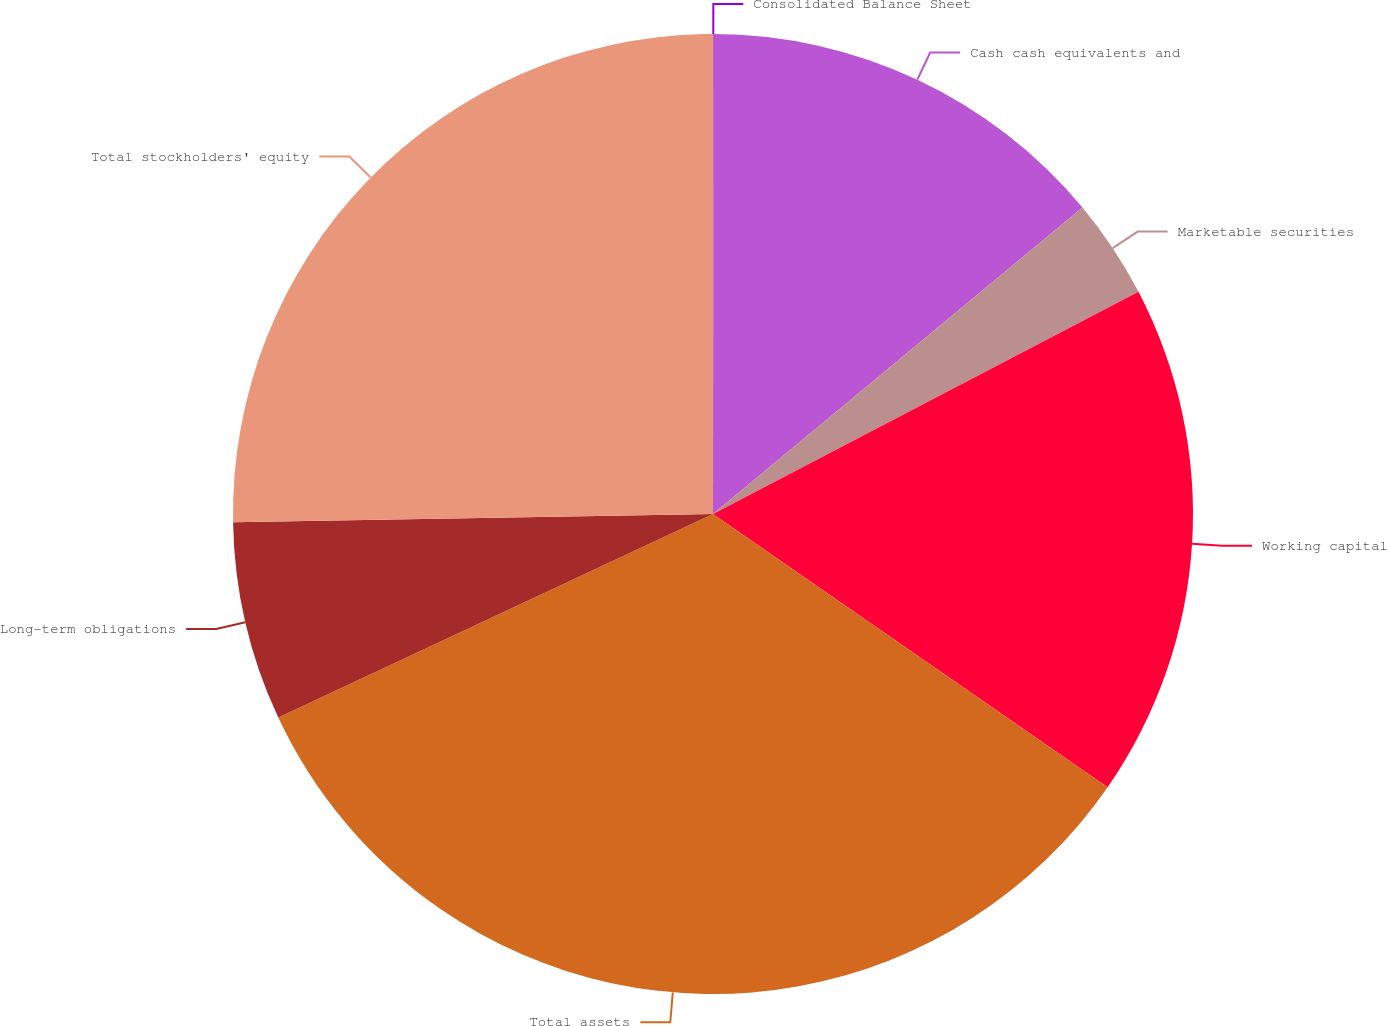Convert chart. <chart><loc_0><loc_0><loc_500><loc_500><pie_chart><fcel>Consolidated Balance Sheet<fcel>Cash cash equivalents and<fcel>Marketable securities<fcel>Working capital<fcel>Total assets<fcel>Long-term obligations<fcel>Total stockholders' equity<nl><fcel>0.02%<fcel>13.96%<fcel>3.36%<fcel>17.3%<fcel>33.39%<fcel>6.7%<fcel>25.27%<nl></chart> 